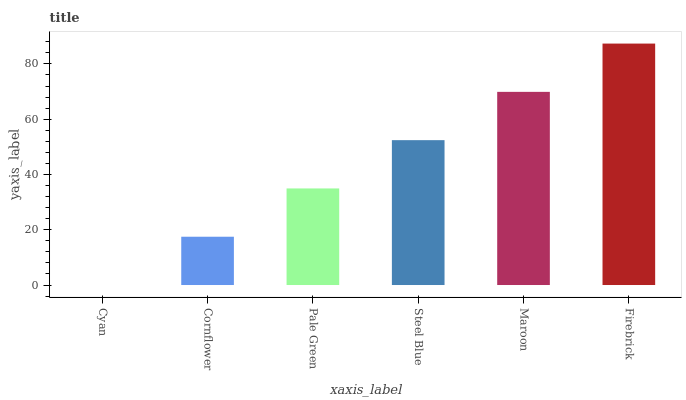Is Cornflower the minimum?
Answer yes or no. No. Is Cornflower the maximum?
Answer yes or no. No. Is Cornflower greater than Cyan?
Answer yes or no. Yes. Is Cyan less than Cornflower?
Answer yes or no. Yes. Is Cyan greater than Cornflower?
Answer yes or no. No. Is Cornflower less than Cyan?
Answer yes or no. No. Is Steel Blue the high median?
Answer yes or no. Yes. Is Pale Green the low median?
Answer yes or no. Yes. Is Pale Green the high median?
Answer yes or no. No. Is Cornflower the low median?
Answer yes or no. No. 